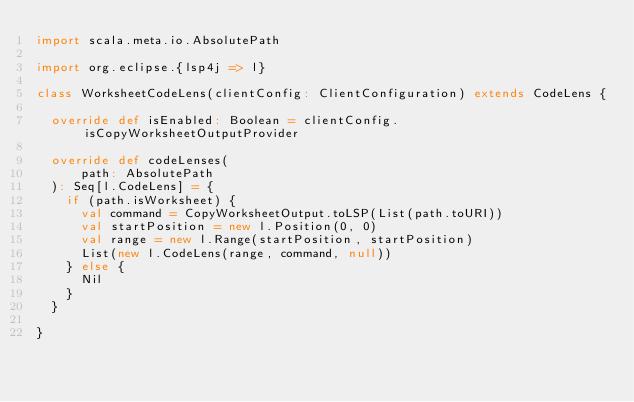<code> <loc_0><loc_0><loc_500><loc_500><_Scala_>import scala.meta.io.AbsolutePath

import org.eclipse.{lsp4j => l}

class WorksheetCodeLens(clientConfig: ClientConfiguration) extends CodeLens {

  override def isEnabled: Boolean = clientConfig.isCopyWorksheetOutputProvider

  override def codeLenses(
      path: AbsolutePath
  ): Seq[l.CodeLens] = {
    if (path.isWorksheet) {
      val command = CopyWorksheetOutput.toLSP(List(path.toURI))
      val startPosition = new l.Position(0, 0)
      val range = new l.Range(startPosition, startPosition)
      List(new l.CodeLens(range, command, null))
    } else {
      Nil
    }
  }

}
</code> 